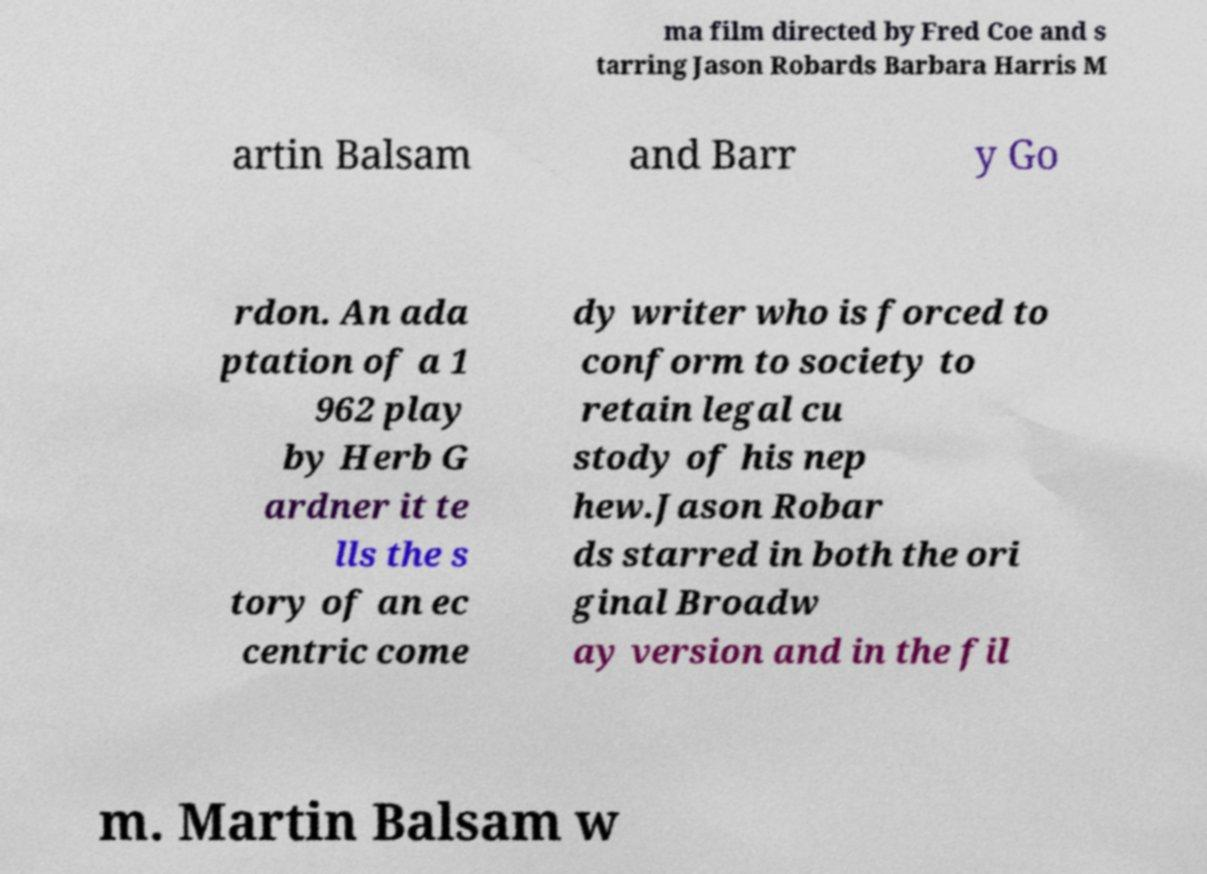There's text embedded in this image that I need extracted. Can you transcribe it verbatim? ma film directed by Fred Coe and s tarring Jason Robards Barbara Harris M artin Balsam and Barr y Go rdon. An ada ptation of a 1 962 play by Herb G ardner it te lls the s tory of an ec centric come dy writer who is forced to conform to society to retain legal cu stody of his nep hew.Jason Robar ds starred in both the ori ginal Broadw ay version and in the fil m. Martin Balsam w 